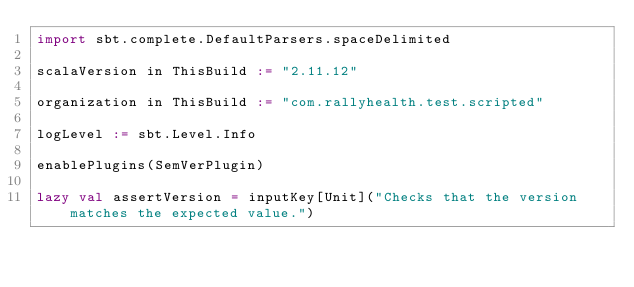<code> <loc_0><loc_0><loc_500><loc_500><_Scala_>import sbt.complete.DefaultParsers.spaceDelimited

scalaVersion in ThisBuild := "2.11.12"

organization in ThisBuild := "com.rallyhealth.test.scripted"

logLevel := sbt.Level.Info

enablePlugins(SemVerPlugin)

lazy val assertVersion = inputKey[Unit]("Checks that the version matches the expected value.")</code> 